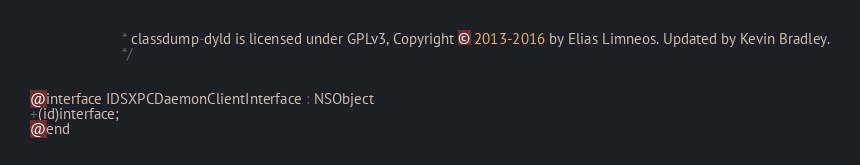<code> <loc_0><loc_0><loc_500><loc_500><_C_>                       * classdump-dyld is licensed under GPLv3, Copyright © 2013-2016 by Elias Limneos. Updated by Kevin Bradley.
                       */


@interface IDSXPCDaemonClientInterface : NSObject
+(id)interface;
@end

</code> 